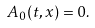<formula> <loc_0><loc_0><loc_500><loc_500>A _ { 0 } ( t , x ) = 0 .</formula> 